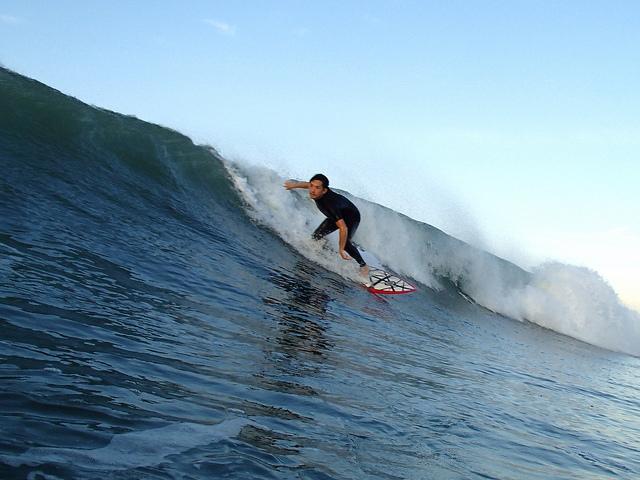How many surfers are riding the waves?
Give a very brief answer. 1. How many people are wearing an orange tee shirt?
Give a very brief answer. 0. 